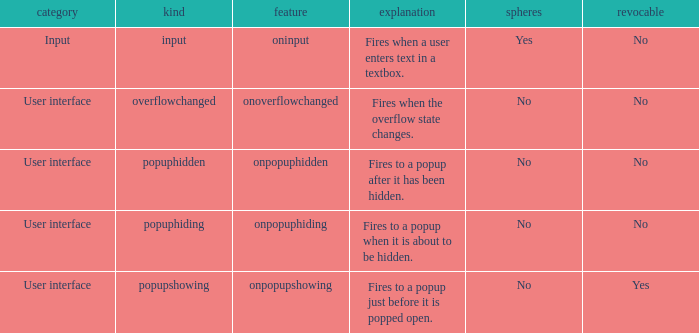What's the type with description being fires when the overflow state changes. Overflowchanged. 